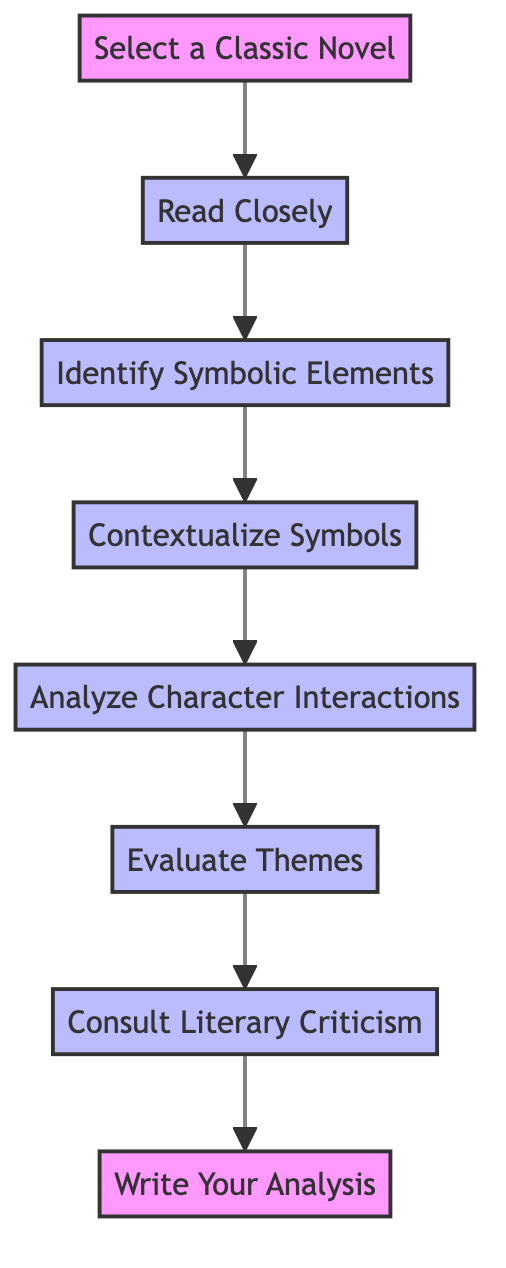What is the first step in the diagram? The first step in the diagram is indicated by the node labeled "Select a Classic Novel." This node is the starting point of the flow chart.
Answer: Select a Classic Novel How many total steps are in the flowchart? By counting each of the nodes in the diagram, there are eight total steps that outline the process of analyzing symbolism in classic novels.
Answer: 8 What is the last step outlined in the diagram? The last step is represented by the node labeled "Write Your Analysis." This concludes the instruction flow on how to analyze symbolism.
Answer: Write Your Analysis Which step comes after "Identify Symbolic Elements"? The order of the nodes shows that after "Identify Symbolic Elements," the next step is "Contextualize Symbols." This is the subsequent action following the identification of symbolic elements.
Answer: Contextualize Symbols What does the step "Analyze Character Interactions" focus on? This step emphasizes examining how different characters relate to the symbolic elements within the novel, which is critical to understanding broader themes.
Answer: Character interactions How does the "Contextualize Symbols" step enrich understanding? This step requires considering various contexts—historical, cultural, and authorial—to grasp the deeper significance of the symbols, reflecting on aspects like the American Dream.
Answer: Significance Identify the process node that immediately follows "Evaluate Themes." The node that immediately follows "Evaluate Themes" is "Consult Literary Criticism." It is the next logical step in this analysis process.
Answer: Consult Literary Criticism What types of literary criticism are suggested in the final steps of the diagram? The diagram suggests consulting various scholarly articles and critical essays, specifically mentioning critics like Harold Bloom or Northrop Frye for diverse perspectives.
Answer: Literary criticism What step involves synthesizing all findings? The step that involves synthesizing all findings into a coherent format, such as an essay or presentation, is "Write Your Analysis." It ties together the earlier steps of analysis.
Answer: Write Your Analysis 